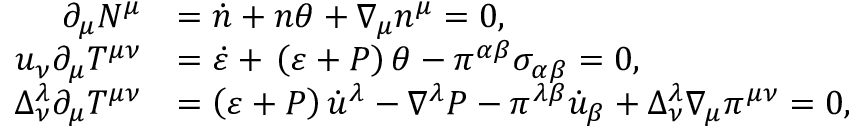<formula> <loc_0><loc_0><loc_500><loc_500>\begin{array} { r l } { \partial _ { \mu } N ^ { \mu } } & { = \dot { n } + n \theta + \nabla _ { \mu } n ^ { \mu } = 0 , } \\ { u _ { \nu } \partial _ { \mu } T ^ { \mu \nu } } & { = \dot { \varepsilon } + \, \left ( \varepsilon + P \right ) \theta - \pi ^ { \alpha \beta } \sigma _ { \alpha \beta } = 0 , } \\ { \Delta _ { \nu } ^ { \lambda } \partial _ { \mu } T ^ { \mu \nu } } & { = \left ( \varepsilon + P \right ) \dot { u } ^ { \lambda } - \nabla ^ { \lambda } P - \pi ^ { \lambda \beta } \dot { u } _ { \beta } + \Delta _ { \nu } ^ { \lambda } \nabla _ { \mu } \pi ^ { \mu \nu } = 0 , } \end{array}</formula> 